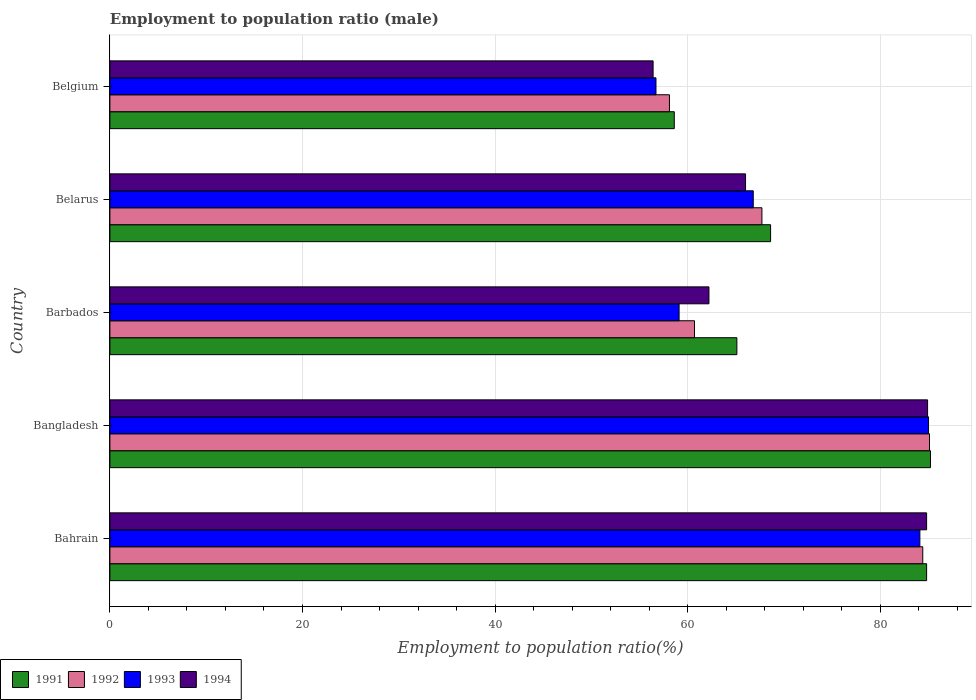How many different coloured bars are there?
Ensure brevity in your answer.  4. How many bars are there on the 4th tick from the top?
Give a very brief answer. 4. What is the label of the 4th group of bars from the top?
Give a very brief answer. Bangladesh. What is the employment to population ratio in 1991 in Bangladesh?
Offer a terse response. 85.2. Across all countries, what is the maximum employment to population ratio in 1993?
Your answer should be compact. 85. Across all countries, what is the minimum employment to population ratio in 1993?
Offer a very short reply. 56.7. In which country was the employment to population ratio in 1994 minimum?
Your response must be concise. Belgium. What is the total employment to population ratio in 1991 in the graph?
Make the answer very short. 362.3. What is the difference between the employment to population ratio in 1992 in Barbados and that in Belgium?
Ensure brevity in your answer.  2.6. What is the difference between the employment to population ratio in 1991 in Bahrain and the employment to population ratio in 1993 in Belarus?
Keep it short and to the point. 18. What is the average employment to population ratio in 1994 per country?
Give a very brief answer. 70.86. What is the difference between the employment to population ratio in 1992 and employment to population ratio in 1991 in Bahrain?
Your answer should be very brief. -0.4. In how many countries, is the employment to population ratio in 1994 greater than 80 %?
Your answer should be very brief. 2. What is the ratio of the employment to population ratio in 1994 in Barbados to that in Belgium?
Give a very brief answer. 1.1. What is the difference between the highest and the second highest employment to population ratio in 1994?
Make the answer very short. 0.1. What is the difference between the highest and the lowest employment to population ratio in 1992?
Ensure brevity in your answer.  27. Is the sum of the employment to population ratio in 1992 in Bahrain and Belgium greater than the maximum employment to population ratio in 1994 across all countries?
Offer a very short reply. Yes. Is it the case that in every country, the sum of the employment to population ratio in 1992 and employment to population ratio in 1994 is greater than the sum of employment to population ratio in 1993 and employment to population ratio in 1991?
Make the answer very short. No. What does the 4th bar from the top in Belarus represents?
Your response must be concise. 1991. What does the 4th bar from the bottom in Barbados represents?
Keep it short and to the point. 1994. Are all the bars in the graph horizontal?
Keep it short and to the point. Yes. What is the difference between two consecutive major ticks on the X-axis?
Your answer should be very brief. 20. Are the values on the major ticks of X-axis written in scientific E-notation?
Keep it short and to the point. No. Does the graph contain grids?
Give a very brief answer. Yes. What is the title of the graph?
Your answer should be compact. Employment to population ratio (male). What is the label or title of the Y-axis?
Your answer should be very brief. Country. What is the Employment to population ratio(%) in 1991 in Bahrain?
Provide a short and direct response. 84.8. What is the Employment to population ratio(%) in 1992 in Bahrain?
Your answer should be very brief. 84.4. What is the Employment to population ratio(%) in 1993 in Bahrain?
Make the answer very short. 84.1. What is the Employment to population ratio(%) of 1994 in Bahrain?
Ensure brevity in your answer.  84.8. What is the Employment to population ratio(%) of 1991 in Bangladesh?
Provide a succinct answer. 85.2. What is the Employment to population ratio(%) of 1992 in Bangladesh?
Your answer should be very brief. 85.1. What is the Employment to population ratio(%) in 1993 in Bangladesh?
Offer a terse response. 85. What is the Employment to population ratio(%) of 1994 in Bangladesh?
Give a very brief answer. 84.9. What is the Employment to population ratio(%) in 1991 in Barbados?
Provide a succinct answer. 65.1. What is the Employment to population ratio(%) in 1992 in Barbados?
Offer a very short reply. 60.7. What is the Employment to population ratio(%) of 1993 in Barbados?
Make the answer very short. 59.1. What is the Employment to population ratio(%) in 1994 in Barbados?
Ensure brevity in your answer.  62.2. What is the Employment to population ratio(%) in 1991 in Belarus?
Your answer should be compact. 68.6. What is the Employment to population ratio(%) in 1992 in Belarus?
Your answer should be compact. 67.7. What is the Employment to population ratio(%) of 1993 in Belarus?
Offer a terse response. 66.8. What is the Employment to population ratio(%) in 1994 in Belarus?
Ensure brevity in your answer.  66. What is the Employment to population ratio(%) in 1991 in Belgium?
Keep it short and to the point. 58.6. What is the Employment to population ratio(%) in 1992 in Belgium?
Make the answer very short. 58.1. What is the Employment to population ratio(%) in 1993 in Belgium?
Offer a terse response. 56.7. What is the Employment to population ratio(%) in 1994 in Belgium?
Make the answer very short. 56.4. Across all countries, what is the maximum Employment to population ratio(%) in 1991?
Ensure brevity in your answer.  85.2. Across all countries, what is the maximum Employment to population ratio(%) of 1992?
Keep it short and to the point. 85.1. Across all countries, what is the maximum Employment to population ratio(%) of 1993?
Provide a succinct answer. 85. Across all countries, what is the maximum Employment to population ratio(%) in 1994?
Keep it short and to the point. 84.9. Across all countries, what is the minimum Employment to population ratio(%) in 1991?
Provide a succinct answer. 58.6. Across all countries, what is the minimum Employment to population ratio(%) of 1992?
Provide a succinct answer. 58.1. Across all countries, what is the minimum Employment to population ratio(%) of 1993?
Ensure brevity in your answer.  56.7. Across all countries, what is the minimum Employment to population ratio(%) in 1994?
Make the answer very short. 56.4. What is the total Employment to population ratio(%) in 1991 in the graph?
Give a very brief answer. 362.3. What is the total Employment to population ratio(%) in 1992 in the graph?
Provide a succinct answer. 356. What is the total Employment to population ratio(%) in 1993 in the graph?
Make the answer very short. 351.7. What is the total Employment to population ratio(%) in 1994 in the graph?
Give a very brief answer. 354.3. What is the difference between the Employment to population ratio(%) of 1991 in Bahrain and that in Bangladesh?
Your answer should be very brief. -0.4. What is the difference between the Employment to population ratio(%) of 1991 in Bahrain and that in Barbados?
Your answer should be very brief. 19.7. What is the difference between the Employment to population ratio(%) in 1992 in Bahrain and that in Barbados?
Make the answer very short. 23.7. What is the difference between the Employment to population ratio(%) in 1993 in Bahrain and that in Barbados?
Ensure brevity in your answer.  25. What is the difference between the Employment to population ratio(%) in 1994 in Bahrain and that in Barbados?
Provide a succinct answer. 22.6. What is the difference between the Employment to population ratio(%) of 1992 in Bahrain and that in Belarus?
Offer a terse response. 16.7. What is the difference between the Employment to population ratio(%) of 1991 in Bahrain and that in Belgium?
Offer a terse response. 26.2. What is the difference between the Employment to population ratio(%) in 1992 in Bahrain and that in Belgium?
Offer a very short reply. 26.3. What is the difference between the Employment to population ratio(%) of 1993 in Bahrain and that in Belgium?
Offer a terse response. 27.4. What is the difference between the Employment to population ratio(%) of 1994 in Bahrain and that in Belgium?
Your response must be concise. 28.4. What is the difference between the Employment to population ratio(%) in 1991 in Bangladesh and that in Barbados?
Make the answer very short. 20.1. What is the difference between the Employment to population ratio(%) in 1992 in Bangladesh and that in Barbados?
Keep it short and to the point. 24.4. What is the difference between the Employment to population ratio(%) in 1993 in Bangladesh and that in Barbados?
Your answer should be compact. 25.9. What is the difference between the Employment to population ratio(%) in 1994 in Bangladesh and that in Barbados?
Make the answer very short. 22.7. What is the difference between the Employment to population ratio(%) in 1992 in Bangladesh and that in Belarus?
Give a very brief answer. 17.4. What is the difference between the Employment to population ratio(%) in 1994 in Bangladesh and that in Belarus?
Provide a succinct answer. 18.9. What is the difference between the Employment to population ratio(%) of 1991 in Bangladesh and that in Belgium?
Give a very brief answer. 26.6. What is the difference between the Employment to population ratio(%) in 1993 in Bangladesh and that in Belgium?
Ensure brevity in your answer.  28.3. What is the difference between the Employment to population ratio(%) of 1991 in Barbados and that in Belarus?
Make the answer very short. -3.5. What is the difference between the Employment to population ratio(%) in 1992 in Barbados and that in Belarus?
Your answer should be compact. -7. What is the difference between the Employment to population ratio(%) in 1993 in Barbados and that in Belarus?
Offer a terse response. -7.7. What is the difference between the Employment to population ratio(%) of 1994 in Barbados and that in Belgium?
Give a very brief answer. 5.8. What is the difference between the Employment to population ratio(%) in 1991 in Belarus and that in Belgium?
Keep it short and to the point. 10. What is the difference between the Employment to population ratio(%) of 1994 in Belarus and that in Belgium?
Your answer should be very brief. 9.6. What is the difference between the Employment to population ratio(%) of 1993 in Bahrain and the Employment to population ratio(%) of 1994 in Bangladesh?
Offer a very short reply. -0.8. What is the difference between the Employment to population ratio(%) in 1991 in Bahrain and the Employment to population ratio(%) in 1992 in Barbados?
Offer a very short reply. 24.1. What is the difference between the Employment to population ratio(%) of 1991 in Bahrain and the Employment to population ratio(%) of 1993 in Barbados?
Provide a short and direct response. 25.7. What is the difference between the Employment to population ratio(%) in 1991 in Bahrain and the Employment to population ratio(%) in 1994 in Barbados?
Your answer should be compact. 22.6. What is the difference between the Employment to population ratio(%) in 1992 in Bahrain and the Employment to population ratio(%) in 1993 in Barbados?
Provide a succinct answer. 25.3. What is the difference between the Employment to population ratio(%) of 1992 in Bahrain and the Employment to population ratio(%) of 1994 in Barbados?
Provide a short and direct response. 22.2. What is the difference between the Employment to population ratio(%) of 1993 in Bahrain and the Employment to population ratio(%) of 1994 in Barbados?
Offer a very short reply. 21.9. What is the difference between the Employment to population ratio(%) in 1991 in Bahrain and the Employment to population ratio(%) in 1994 in Belarus?
Offer a very short reply. 18.8. What is the difference between the Employment to population ratio(%) of 1992 in Bahrain and the Employment to population ratio(%) of 1993 in Belarus?
Provide a succinct answer. 17.6. What is the difference between the Employment to population ratio(%) of 1991 in Bahrain and the Employment to population ratio(%) of 1992 in Belgium?
Your answer should be very brief. 26.7. What is the difference between the Employment to population ratio(%) of 1991 in Bahrain and the Employment to population ratio(%) of 1993 in Belgium?
Give a very brief answer. 28.1. What is the difference between the Employment to population ratio(%) of 1991 in Bahrain and the Employment to population ratio(%) of 1994 in Belgium?
Your answer should be very brief. 28.4. What is the difference between the Employment to population ratio(%) of 1992 in Bahrain and the Employment to population ratio(%) of 1993 in Belgium?
Give a very brief answer. 27.7. What is the difference between the Employment to population ratio(%) in 1992 in Bahrain and the Employment to population ratio(%) in 1994 in Belgium?
Provide a short and direct response. 28. What is the difference between the Employment to population ratio(%) in 1993 in Bahrain and the Employment to population ratio(%) in 1994 in Belgium?
Keep it short and to the point. 27.7. What is the difference between the Employment to population ratio(%) of 1991 in Bangladesh and the Employment to population ratio(%) of 1992 in Barbados?
Your response must be concise. 24.5. What is the difference between the Employment to population ratio(%) of 1991 in Bangladesh and the Employment to population ratio(%) of 1993 in Barbados?
Ensure brevity in your answer.  26.1. What is the difference between the Employment to population ratio(%) in 1991 in Bangladesh and the Employment to population ratio(%) in 1994 in Barbados?
Offer a terse response. 23. What is the difference between the Employment to population ratio(%) in 1992 in Bangladesh and the Employment to population ratio(%) in 1994 in Barbados?
Give a very brief answer. 22.9. What is the difference between the Employment to population ratio(%) in 1993 in Bangladesh and the Employment to population ratio(%) in 1994 in Barbados?
Your answer should be compact. 22.8. What is the difference between the Employment to population ratio(%) in 1991 in Bangladesh and the Employment to population ratio(%) in 1992 in Belarus?
Your response must be concise. 17.5. What is the difference between the Employment to population ratio(%) in 1991 in Bangladesh and the Employment to population ratio(%) in 1993 in Belarus?
Make the answer very short. 18.4. What is the difference between the Employment to population ratio(%) of 1991 in Bangladesh and the Employment to population ratio(%) of 1994 in Belarus?
Give a very brief answer. 19.2. What is the difference between the Employment to population ratio(%) of 1992 in Bangladesh and the Employment to population ratio(%) of 1994 in Belarus?
Provide a succinct answer. 19.1. What is the difference between the Employment to population ratio(%) in 1991 in Bangladesh and the Employment to population ratio(%) in 1992 in Belgium?
Offer a terse response. 27.1. What is the difference between the Employment to population ratio(%) in 1991 in Bangladesh and the Employment to population ratio(%) in 1994 in Belgium?
Your answer should be compact. 28.8. What is the difference between the Employment to population ratio(%) in 1992 in Bangladesh and the Employment to population ratio(%) in 1993 in Belgium?
Provide a succinct answer. 28.4. What is the difference between the Employment to population ratio(%) in 1992 in Bangladesh and the Employment to population ratio(%) in 1994 in Belgium?
Keep it short and to the point. 28.7. What is the difference between the Employment to population ratio(%) in 1993 in Bangladesh and the Employment to population ratio(%) in 1994 in Belgium?
Your answer should be very brief. 28.6. What is the difference between the Employment to population ratio(%) of 1991 in Barbados and the Employment to population ratio(%) of 1992 in Belarus?
Offer a very short reply. -2.6. What is the difference between the Employment to population ratio(%) of 1991 in Barbados and the Employment to population ratio(%) of 1994 in Belarus?
Offer a terse response. -0.9. What is the difference between the Employment to population ratio(%) in 1993 in Barbados and the Employment to population ratio(%) in 1994 in Belarus?
Keep it short and to the point. -6.9. What is the difference between the Employment to population ratio(%) in 1991 in Barbados and the Employment to population ratio(%) in 1992 in Belgium?
Give a very brief answer. 7. What is the difference between the Employment to population ratio(%) in 1991 in Barbados and the Employment to population ratio(%) in 1993 in Belgium?
Your answer should be compact. 8.4. What is the difference between the Employment to population ratio(%) in 1992 in Barbados and the Employment to population ratio(%) in 1994 in Belgium?
Provide a succinct answer. 4.3. What is the difference between the Employment to population ratio(%) in 1993 in Barbados and the Employment to population ratio(%) in 1994 in Belgium?
Provide a short and direct response. 2.7. What is the difference between the Employment to population ratio(%) of 1991 in Belarus and the Employment to population ratio(%) of 1993 in Belgium?
Make the answer very short. 11.9. What is the difference between the Employment to population ratio(%) in 1991 in Belarus and the Employment to population ratio(%) in 1994 in Belgium?
Give a very brief answer. 12.2. What is the difference between the Employment to population ratio(%) of 1992 in Belarus and the Employment to population ratio(%) of 1993 in Belgium?
Offer a terse response. 11. What is the difference between the Employment to population ratio(%) of 1992 in Belarus and the Employment to population ratio(%) of 1994 in Belgium?
Provide a short and direct response. 11.3. What is the average Employment to population ratio(%) of 1991 per country?
Provide a succinct answer. 72.46. What is the average Employment to population ratio(%) of 1992 per country?
Offer a terse response. 71.2. What is the average Employment to population ratio(%) in 1993 per country?
Your answer should be compact. 70.34. What is the average Employment to population ratio(%) in 1994 per country?
Your response must be concise. 70.86. What is the difference between the Employment to population ratio(%) in 1991 and Employment to population ratio(%) in 1992 in Bahrain?
Offer a terse response. 0.4. What is the difference between the Employment to population ratio(%) of 1991 and Employment to population ratio(%) of 1994 in Bahrain?
Make the answer very short. 0. What is the difference between the Employment to population ratio(%) of 1991 and Employment to population ratio(%) of 1992 in Bangladesh?
Offer a very short reply. 0.1. What is the difference between the Employment to population ratio(%) in 1992 and Employment to population ratio(%) in 1993 in Bangladesh?
Give a very brief answer. 0.1. What is the difference between the Employment to population ratio(%) of 1992 and Employment to population ratio(%) of 1994 in Barbados?
Your answer should be very brief. -1.5. What is the difference between the Employment to population ratio(%) in 1991 and Employment to population ratio(%) in 1993 in Belarus?
Make the answer very short. 1.8. What is the difference between the Employment to population ratio(%) in 1991 and Employment to population ratio(%) in 1994 in Belarus?
Your answer should be compact. 2.6. What is the difference between the Employment to population ratio(%) in 1992 and Employment to population ratio(%) in 1993 in Belarus?
Your answer should be compact. 0.9. What is the difference between the Employment to population ratio(%) in 1992 and Employment to population ratio(%) in 1994 in Belarus?
Keep it short and to the point. 1.7. What is the difference between the Employment to population ratio(%) of 1993 and Employment to population ratio(%) of 1994 in Belarus?
Make the answer very short. 0.8. What is the difference between the Employment to population ratio(%) in 1991 and Employment to population ratio(%) in 1992 in Belgium?
Keep it short and to the point. 0.5. What is the difference between the Employment to population ratio(%) of 1991 and Employment to population ratio(%) of 1994 in Belgium?
Offer a terse response. 2.2. What is the difference between the Employment to population ratio(%) of 1992 and Employment to population ratio(%) of 1994 in Belgium?
Ensure brevity in your answer.  1.7. What is the difference between the Employment to population ratio(%) in 1993 and Employment to population ratio(%) in 1994 in Belgium?
Your answer should be compact. 0.3. What is the ratio of the Employment to population ratio(%) in 1991 in Bahrain to that in Bangladesh?
Offer a very short reply. 1. What is the ratio of the Employment to population ratio(%) in 1992 in Bahrain to that in Bangladesh?
Ensure brevity in your answer.  0.99. What is the ratio of the Employment to population ratio(%) of 1994 in Bahrain to that in Bangladesh?
Offer a terse response. 1. What is the ratio of the Employment to population ratio(%) in 1991 in Bahrain to that in Barbados?
Ensure brevity in your answer.  1.3. What is the ratio of the Employment to population ratio(%) in 1992 in Bahrain to that in Barbados?
Your response must be concise. 1.39. What is the ratio of the Employment to population ratio(%) of 1993 in Bahrain to that in Barbados?
Your answer should be very brief. 1.42. What is the ratio of the Employment to population ratio(%) of 1994 in Bahrain to that in Barbados?
Give a very brief answer. 1.36. What is the ratio of the Employment to population ratio(%) in 1991 in Bahrain to that in Belarus?
Your answer should be very brief. 1.24. What is the ratio of the Employment to population ratio(%) in 1992 in Bahrain to that in Belarus?
Provide a succinct answer. 1.25. What is the ratio of the Employment to population ratio(%) in 1993 in Bahrain to that in Belarus?
Make the answer very short. 1.26. What is the ratio of the Employment to population ratio(%) in 1994 in Bahrain to that in Belarus?
Make the answer very short. 1.28. What is the ratio of the Employment to population ratio(%) of 1991 in Bahrain to that in Belgium?
Offer a very short reply. 1.45. What is the ratio of the Employment to population ratio(%) of 1992 in Bahrain to that in Belgium?
Provide a succinct answer. 1.45. What is the ratio of the Employment to population ratio(%) in 1993 in Bahrain to that in Belgium?
Provide a short and direct response. 1.48. What is the ratio of the Employment to population ratio(%) in 1994 in Bahrain to that in Belgium?
Your response must be concise. 1.5. What is the ratio of the Employment to population ratio(%) of 1991 in Bangladesh to that in Barbados?
Provide a succinct answer. 1.31. What is the ratio of the Employment to population ratio(%) in 1992 in Bangladesh to that in Barbados?
Your answer should be compact. 1.4. What is the ratio of the Employment to population ratio(%) in 1993 in Bangladesh to that in Barbados?
Offer a very short reply. 1.44. What is the ratio of the Employment to population ratio(%) in 1994 in Bangladesh to that in Barbados?
Offer a very short reply. 1.36. What is the ratio of the Employment to population ratio(%) in 1991 in Bangladesh to that in Belarus?
Offer a very short reply. 1.24. What is the ratio of the Employment to population ratio(%) of 1992 in Bangladesh to that in Belarus?
Your response must be concise. 1.26. What is the ratio of the Employment to population ratio(%) of 1993 in Bangladesh to that in Belarus?
Make the answer very short. 1.27. What is the ratio of the Employment to population ratio(%) of 1994 in Bangladesh to that in Belarus?
Offer a very short reply. 1.29. What is the ratio of the Employment to population ratio(%) in 1991 in Bangladesh to that in Belgium?
Provide a succinct answer. 1.45. What is the ratio of the Employment to population ratio(%) of 1992 in Bangladesh to that in Belgium?
Ensure brevity in your answer.  1.46. What is the ratio of the Employment to population ratio(%) in 1993 in Bangladesh to that in Belgium?
Offer a very short reply. 1.5. What is the ratio of the Employment to population ratio(%) in 1994 in Bangladesh to that in Belgium?
Your response must be concise. 1.51. What is the ratio of the Employment to population ratio(%) of 1991 in Barbados to that in Belarus?
Keep it short and to the point. 0.95. What is the ratio of the Employment to population ratio(%) in 1992 in Barbados to that in Belarus?
Provide a short and direct response. 0.9. What is the ratio of the Employment to population ratio(%) in 1993 in Barbados to that in Belarus?
Provide a short and direct response. 0.88. What is the ratio of the Employment to population ratio(%) of 1994 in Barbados to that in Belarus?
Give a very brief answer. 0.94. What is the ratio of the Employment to population ratio(%) of 1991 in Barbados to that in Belgium?
Give a very brief answer. 1.11. What is the ratio of the Employment to population ratio(%) of 1992 in Barbados to that in Belgium?
Your response must be concise. 1.04. What is the ratio of the Employment to population ratio(%) of 1993 in Barbados to that in Belgium?
Your response must be concise. 1.04. What is the ratio of the Employment to population ratio(%) of 1994 in Barbados to that in Belgium?
Offer a terse response. 1.1. What is the ratio of the Employment to population ratio(%) of 1991 in Belarus to that in Belgium?
Your answer should be compact. 1.17. What is the ratio of the Employment to population ratio(%) of 1992 in Belarus to that in Belgium?
Your response must be concise. 1.17. What is the ratio of the Employment to population ratio(%) of 1993 in Belarus to that in Belgium?
Ensure brevity in your answer.  1.18. What is the ratio of the Employment to population ratio(%) of 1994 in Belarus to that in Belgium?
Provide a succinct answer. 1.17. What is the difference between the highest and the second highest Employment to population ratio(%) of 1993?
Your response must be concise. 0.9. What is the difference between the highest and the second highest Employment to population ratio(%) in 1994?
Give a very brief answer. 0.1. What is the difference between the highest and the lowest Employment to population ratio(%) in 1991?
Your response must be concise. 26.6. What is the difference between the highest and the lowest Employment to population ratio(%) in 1993?
Offer a very short reply. 28.3. What is the difference between the highest and the lowest Employment to population ratio(%) in 1994?
Provide a succinct answer. 28.5. 